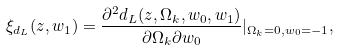<formula> <loc_0><loc_0><loc_500><loc_500>\xi _ { d _ { L } } ( z , w _ { 1 } ) = \frac { \partial ^ { 2 } d _ { L } ( z , \Omega _ { k } , w _ { 0 } , w _ { 1 } ) } { \partial \Omega _ { k } \partial w _ { 0 } } | _ { \Omega _ { k } = 0 , w _ { 0 } = - 1 } ,</formula> 